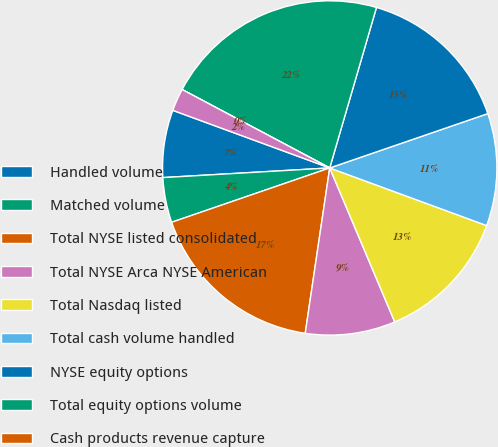<chart> <loc_0><loc_0><loc_500><loc_500><pie_chart><fcel>Handled volume<fcel>Matched volume<fcel>Total NYSE listed consolidated<fcel>Total NYSE Arca NYSE American<fcel>Total Nasdaq listed<fcel>Total cash volume handled<fcel>NYSE equity options<fcel>Total equity options volume<fcel>Cash products revenue capture<fcel>Equity options rate per<nl><fcel>6.52%<fcel>4.35%<fcel>17.39%<fcel>8.7%<fcel>13.04%<fcel>10.87%<fcel>15.22%<fcel>21.74%<fcel>0.0%<fcel>2.17%<nl></chart> 